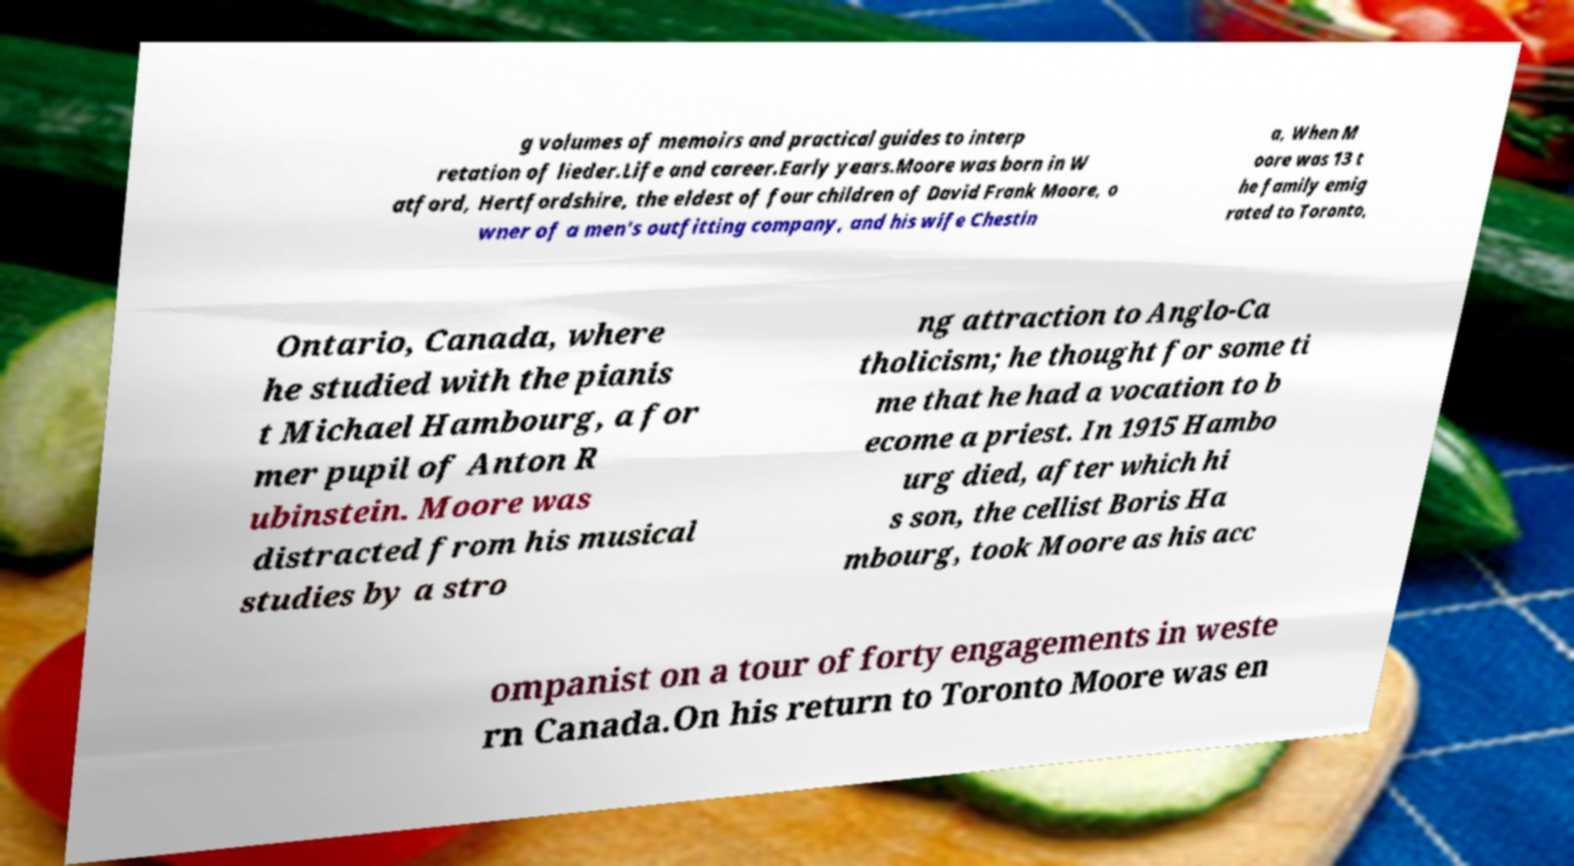Could you extract and type out the text from this image? g volumes of memoirs and practical guides to interp retation of lieder.Life and career.Early years.Moore was born in W atford, Hertfordshire, the eldest of four children of David Frank Moore, o wner of a men's outfitting company, and his wife Chestin a, When M oore was 13 t he family emig rated to Toronto, Ontario, Canada, where he studied with the pianis t Michael Hambourg, a for mer pupil of Anton R ubinstein. Moore was distracted from his musical studies by a stro ng attraction to Anglo-Ca tholicism; he thought for some ti me that he had a vocation to b ecome a priest. In 1915 Hambo urg died, after which hi s son, the cellist Boris Ha mbourg, took Moore as his acc ompanist on a tour of forty engagements in weste rn Canada.On his return to Toronto Moore was en 